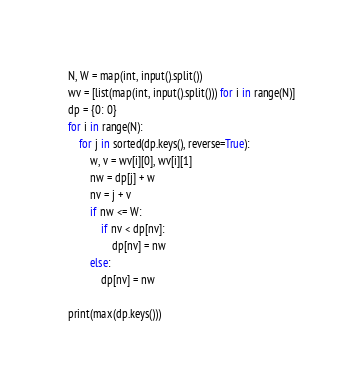<code> <loc_0><loc_0><loc_500><loc_500><_Python_>N, W = map(int, input().split())
wv = [list(map(int, input().split())) for i in range(N)]
dp = {0: 0}
for i in range(N):
    for j in sorted(dp.keys(), reverse=True):
        w, v = wv[i][0], wv[i][1]
        nw = dp[j] + w
        nv = j + v
        if nw <= W:
            if nv < dp[nv]:
                dp[nv] = nw
        else:
            dp[nv] = nw

print(max(dp.keys()))</code> 